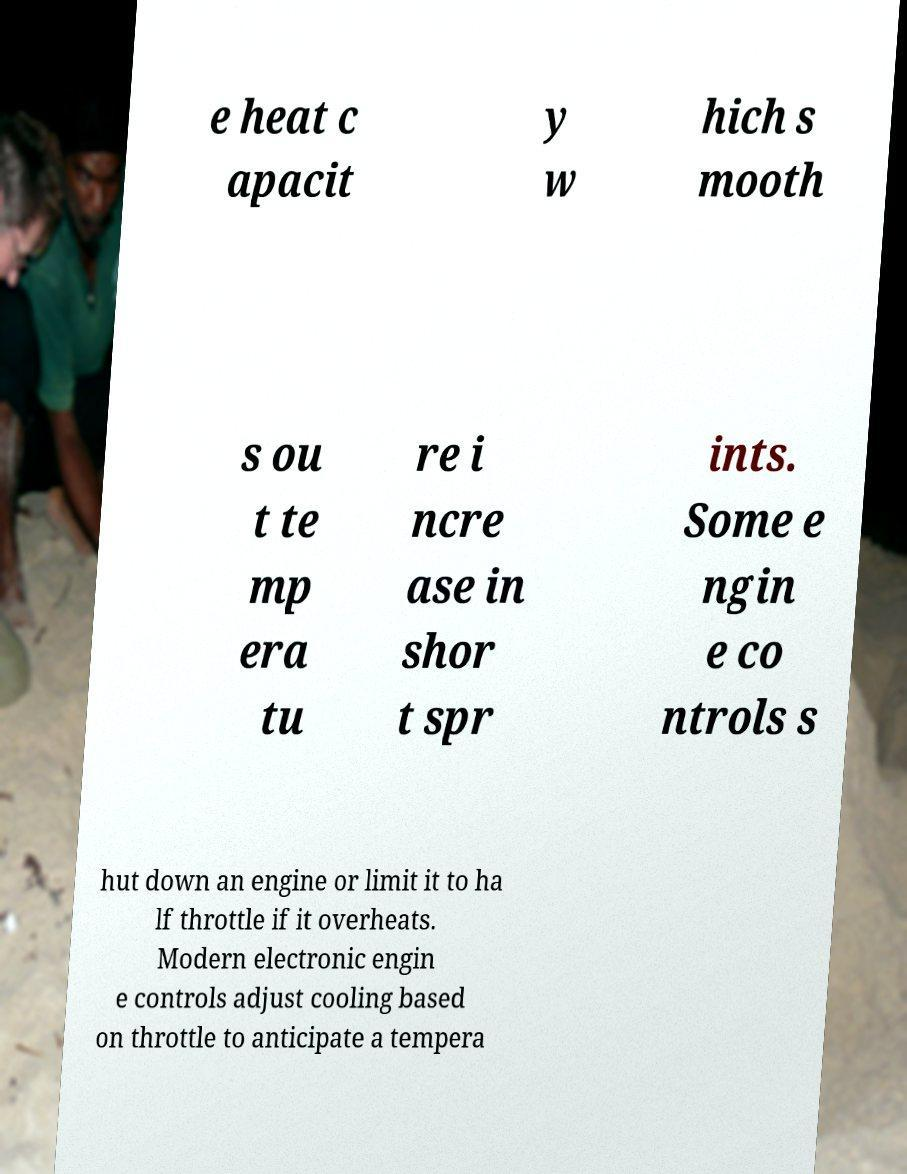There's text embedded in this image that I need extracted. Can you transcribe it verbatim? e heat c apacit y w hich s mooth s ou t te mp era tu re i ncre ase in shor t spr ints. Some e ngin e co ntrols s hut down an engine or limit it to ha lf throttle if it overheats. Modern electronic engin e controls adjust cooling based on throttle to anticipate a tempera 